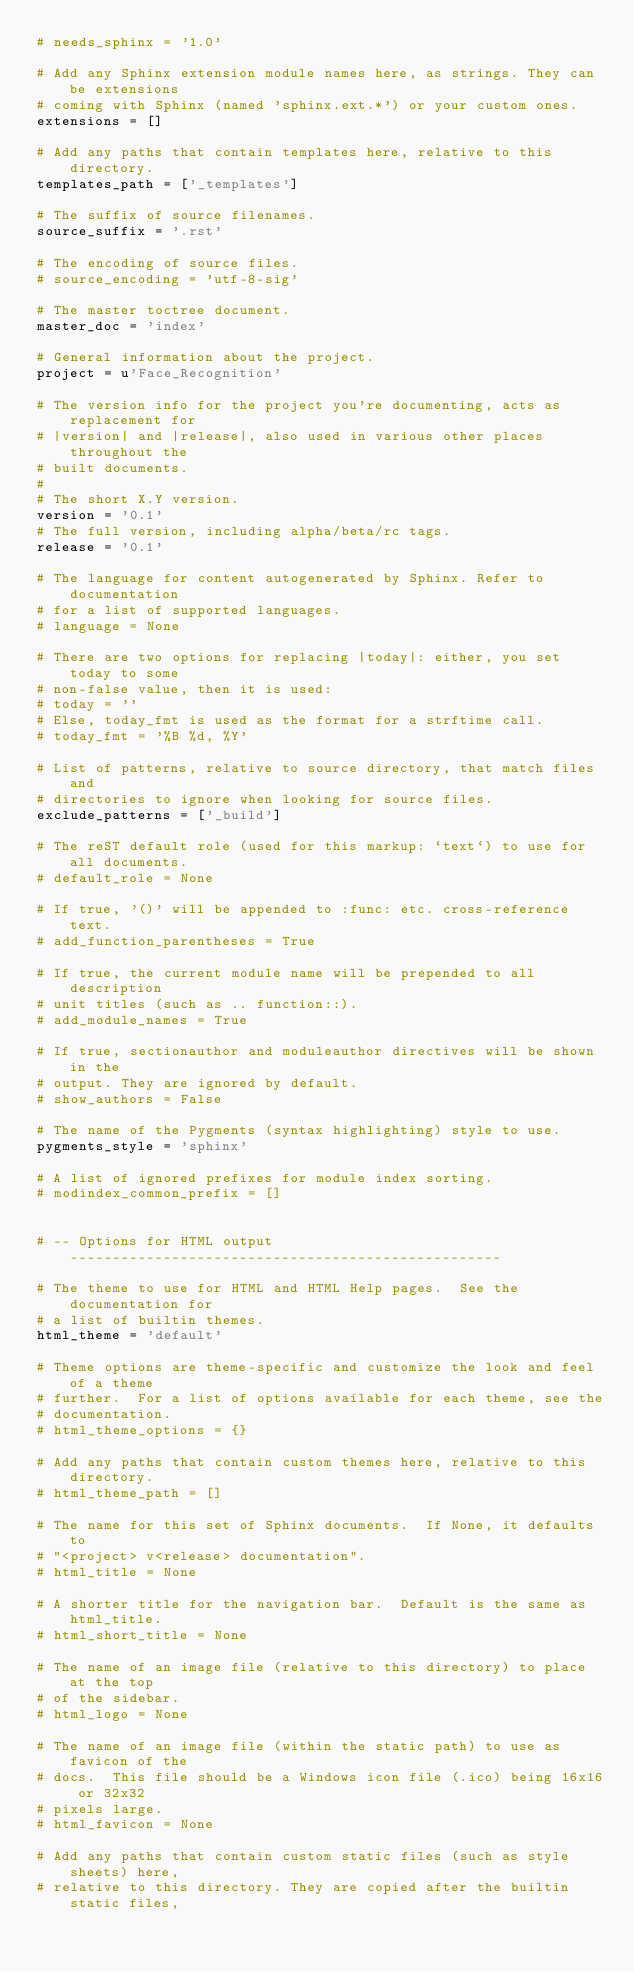Convert code to text. <code><loc_0><loc_0><loc_500><loc_500><_Python_># needs_sphinx = '1.0'

# Add any Sphinx extension module names here, as strings. They can be extensions
# coming with Sphinx (named 'sphinx.ext.*') or your custom ones.
extensions = []

# Add any paths that contain templates here, relative to this directory.
templates_path = ['_templates']

# The suffix of source filenames.
source_suffix = '.rst'

# The encoding of source files.
# source_encoding = 'utf-8-sig'

# The master toctree document.
master_doc = 'index'

# General information about the project.
project = u'Face_Recognition'

# The version info for the project you're documenting, acts as replacement for
# |version| and |release|, also used in various other places throughout the
# built documents.
#
# The short X.Y version.
version = '0.1'
# The full version, including alpha/beta/rc tags.
release = '0.1'

# The language for content autogenerated by Sphinx. Refer to documentation
# for a list of supported languages.
# language = None

# There are two options for replacing |today|: either, you set today to some
# non-false value, then it is used:
# today = ''
# Else, today_fmt is used as the format for a strftime call.
# today_fmt = '%B %d, %Y'

# List of patterns, relative to source directory, that match files and
# directories to ignore when looking for source files.
exclude_patterns = ['_build']

# The reST default role (used for this markup: `text`) to use for all documents.
# default_role = None

# If true, '()' will be appended to :func: etc. cross-reference text.
# add_function_parentheses = True

# If true, the current module name will be prepended to all description
# unit titles (such as .. function::).
# add_module_names = True

# If true, sectionauthor and moduleauthor directives will be shown in the
# output. They are ignored by default.
# show_authors = False

# The name of the Pygments (syntax highlighting) style to use.
pygments_style = 'sphinx'

# A list of ignored prefixes for module index sorting.
# modindex_common_prefix = []


# -- Options for HTML output ---------------------------------------------------

# The theme to use for HTML and HTML Help pages.  See the documentation for
# a list of builtin themes.
html_theme = 'default'

# Theme options are theme-specific and customize the look and feel of a theme
# further.  For a list of options available for each theme, see the
# documentation.
# html_theme_options = {}

# Add any paths that contain custom themes here, relative to this directory.
# html_theme_path = []

# The name for this set of Sphinx documents.  If None, it defaults to
# "<project> v<release> documentation".
# html_title = None

# A shorter title for the navigation bar.  Default is the same as html_title.
# html_short_title = None

# The name of an image file (relative to this directory) to place at the top
# of the sidebar.
# html_logo = None

# The name of an image file (within the static path) to use as favicon of the
# docs.  This file should be a Windows icon file (.ico) being 16x16 or 32x32
# pixels large.
# html_favicon = None

# Add any paths that contain custom static files (such as style sheets) here,
# relative to this directory. They are copied after the builtin static files,</code> 